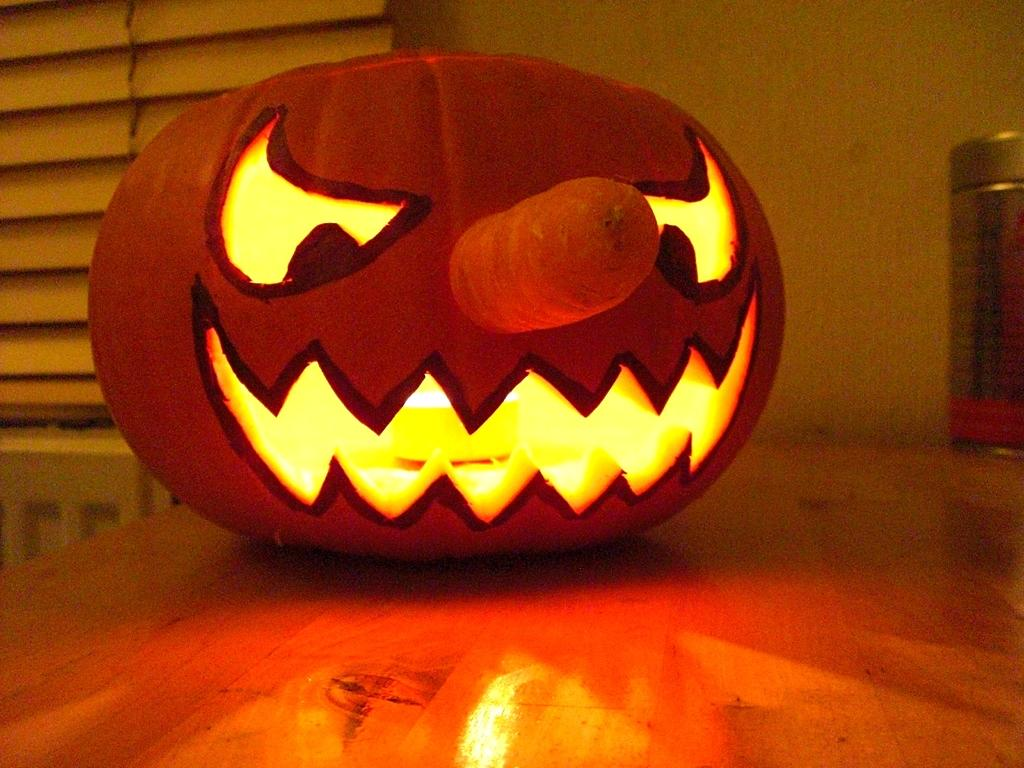What is the main object on the platform in the image? There is a pumpkin on a platform in the image. What can be seen in the background of the image? There is a wall visible in the background of the image. Can you describe any other objects present in the background? There are objects present in the background of the image, but their specific details are not mentioned in the provided facts. What type of linen is draped over the pumpkin in the image? There is no linen present in the image, and the pumpkin is not draped with any fabric. 